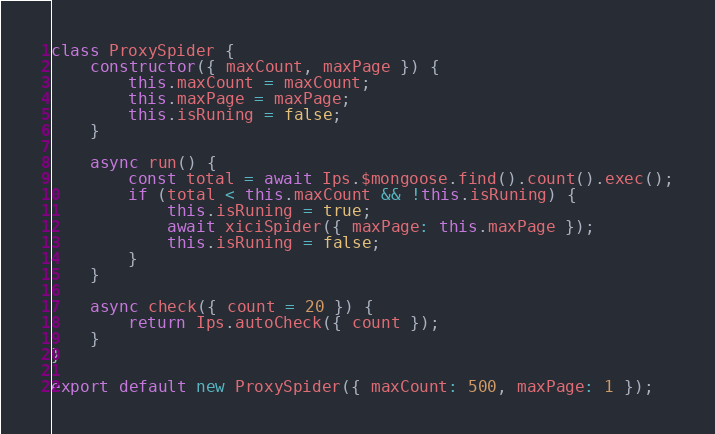Convert code to text. <code><loc_0><loc_0><loc_500><loc_500><_JavaScript_>class ProxySpider {
	constructor({ maxCount, maxPage }) {
		this.maxCount = maxCount;
		this.maxPage = maxPage;
		this.isRuning = false;
	}

	async run() {
		const total = await Ips.$mongoose.find().count().exec();
		if (total < this.maxCount && !this.isRuning) {
			this.isRuning = true;
			await xiciSpider({ maxPage: this.maxPage });
			this.isRuning = false;
		}
	}

	async check({ count = 20 }) {
		return Ips.autoCheck({ count });
	}
}

export default new ProxySpider({ maxCount: 500, maxPage: 1 });
</code> 